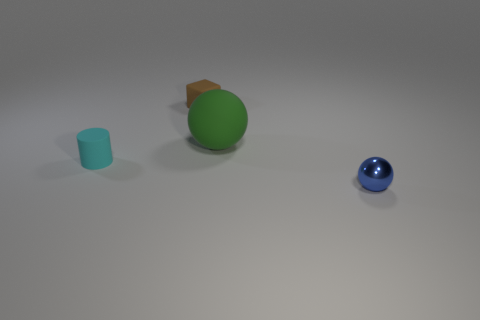There is a blue shiny object in front of the cyan object; is its size the same as the tiny cyan rubber thing?
Offer a very short reply. Yes. How many other things are made of the same material as the cyan thing?
Your response must be concise. 2. Is the number of tiny cylinders greater than the number of tiny yellow shiny spheres?
Keep it short and to the point. Yes. There is a object to the right of the sphere that is behind the object that is on the left side of the rubber block; what is it made of?
Offer a very short reply. Metal. Does the cylinder have the same color as the tiny metallic object?
Offer a terse response. No. Are there any tiny metal objects that have the same color as the big ball?
Keep it short and to the point. No. There is a blue object that is the same size as the brown object; what shape is it?
Provide a short and direct response. Sphere. Is the number of tiny red cylinders less than the number of shiny spheres?
Provide a short and direct response. Yes. How many cyan rubber things have the same size as the matte block?
Provide a short and direct response. 1. What is the tiny cyan cylinder made of?
Give a very brief answer. Rubber. 